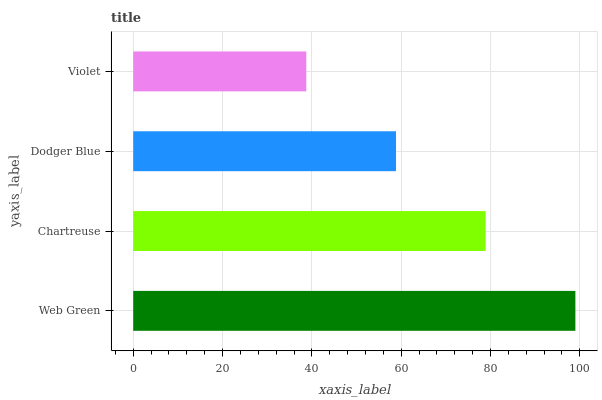Is Violet the minimum?
Answer yes or no. Yes. Is Web Green the maximum?
Answer yes or no. Yes. Is Chartreuse the minimum?
Answer yes or no. No. Is Chartreuse the maximum?
Answer yes or no. No. Is Web Green greater than Chartreuse?
Answer yes or no. Yes. Is Chartreuse less than Web Green?
Answer yes or no. Yes. Is Chartreuse greater than Web Green?
Answer yes or no. No. Is Web Green less than Chartreuse?
Answer yes or no. No. Is Chartreuse the high median?
Answer yes or no. Yes. Is Dodger Blue the low median?
Answer yes or no. Yes. Is Web Green the high median?
Answer yes or no. No. Is Chartreuse the low median?
Answer yes or no. No. 